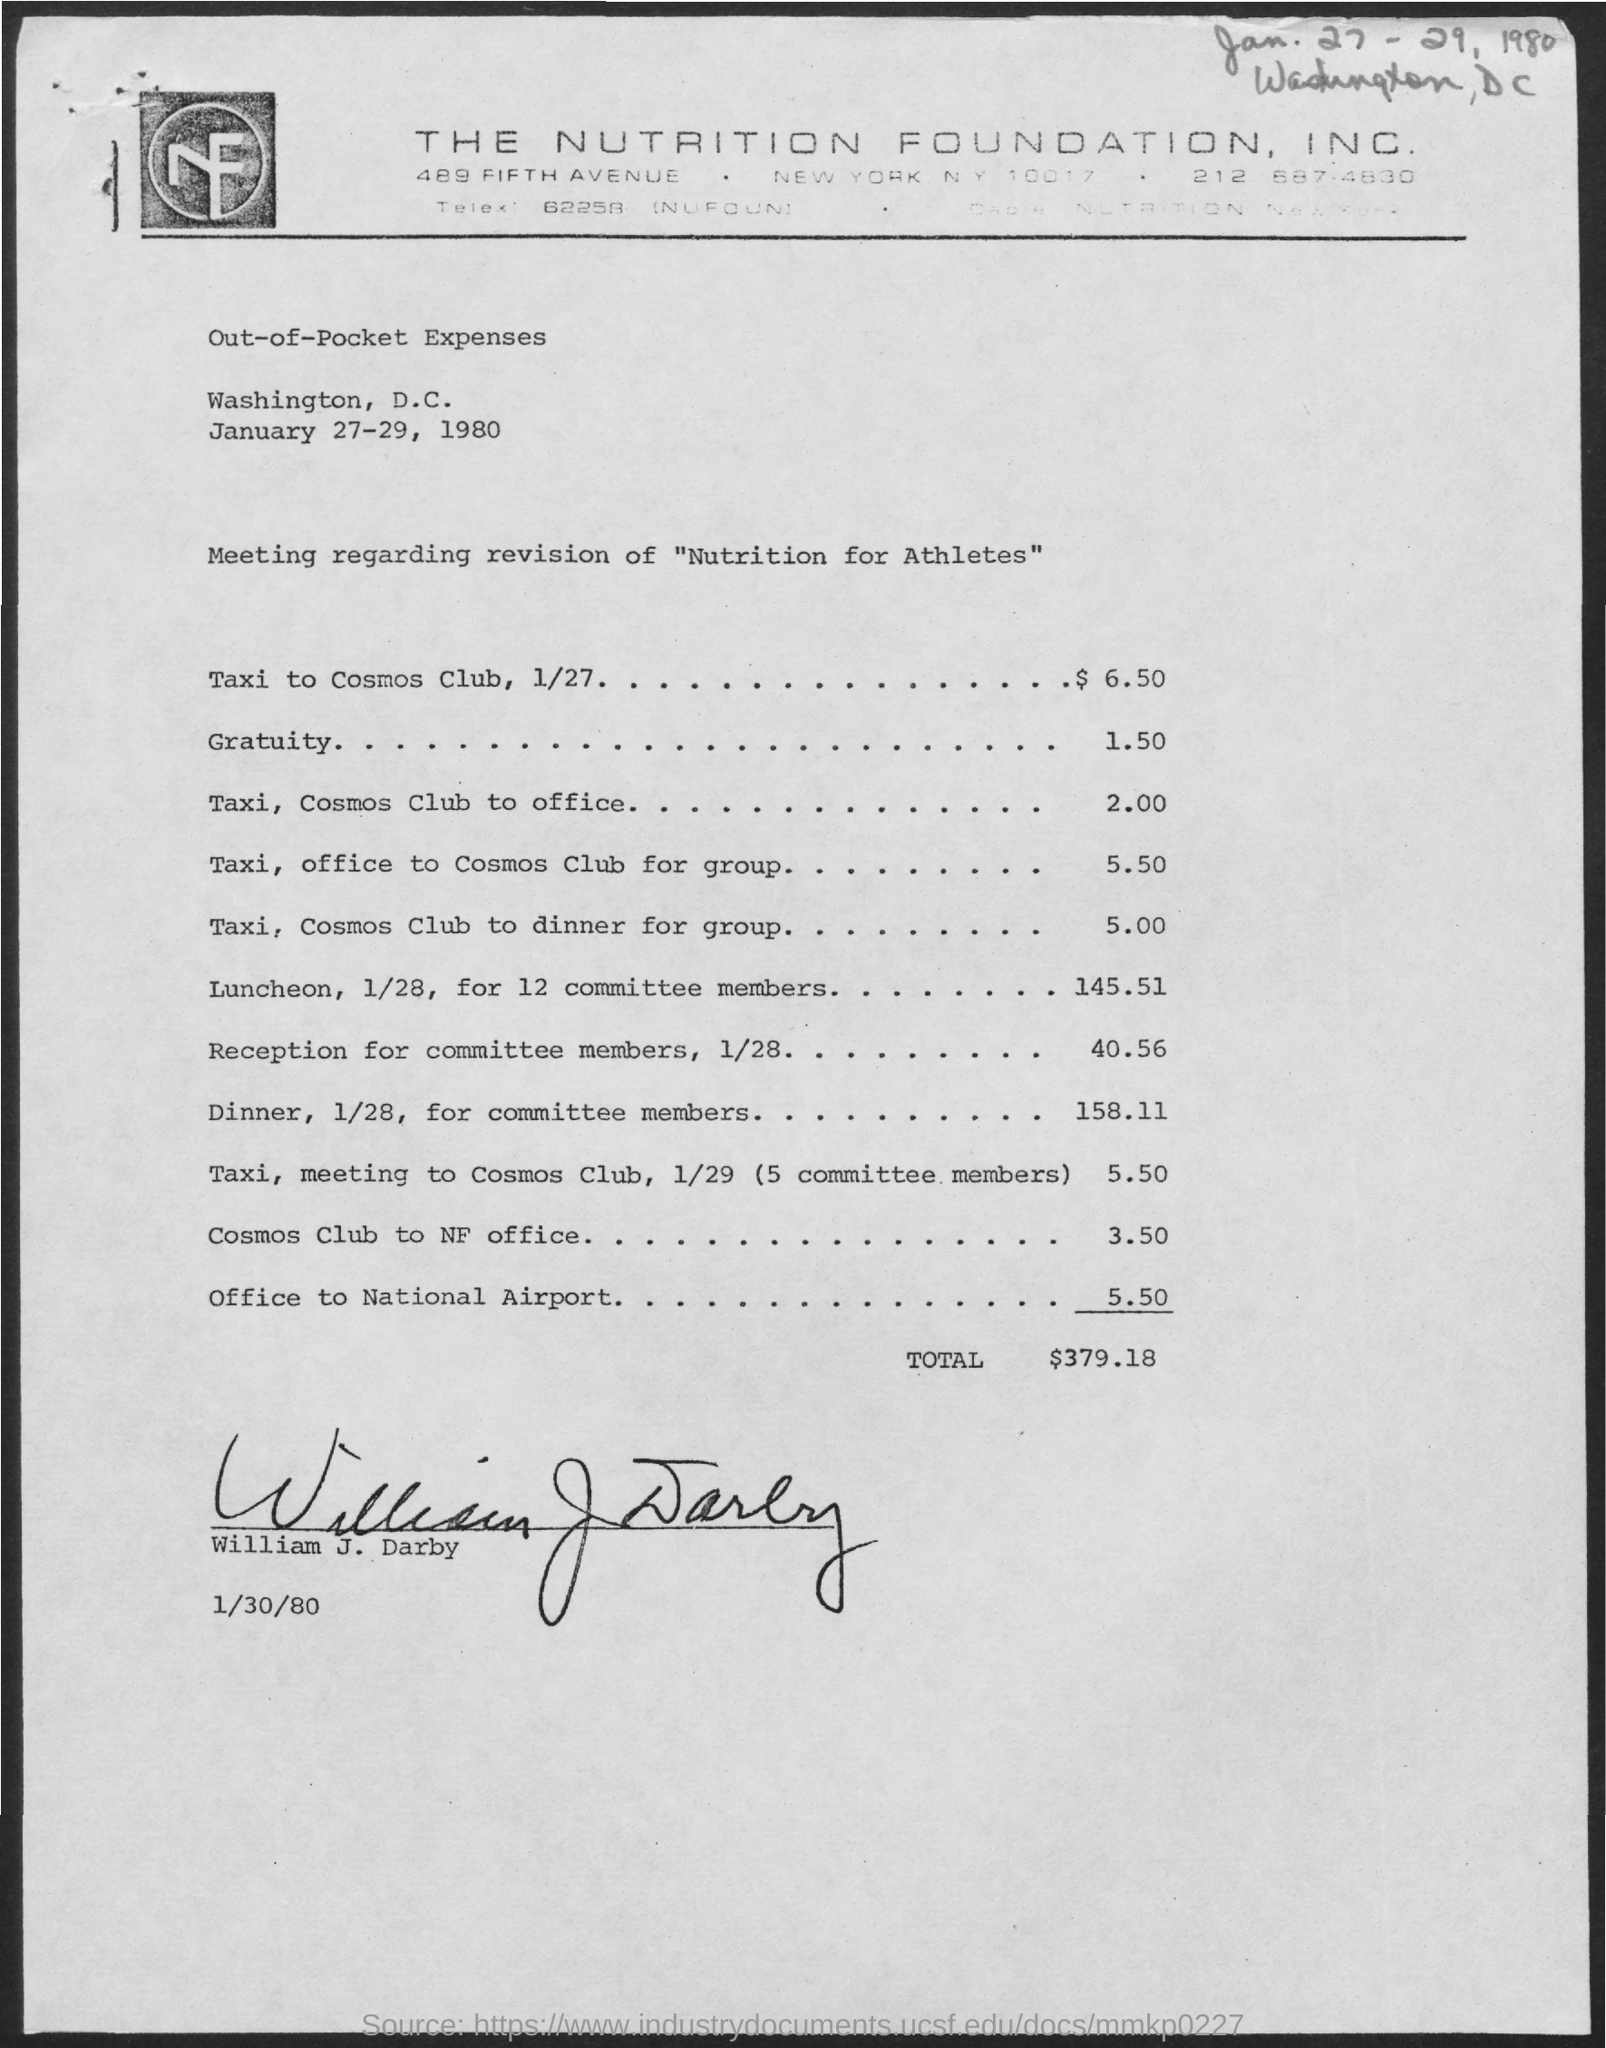Point out several critical features in this image. The Nutrition Foundation, Inc. is mentioned in the header of the document. The document has been signed by William J. Darby. The total out-of-pocket expenses, as stated in the document, is $379.18. 